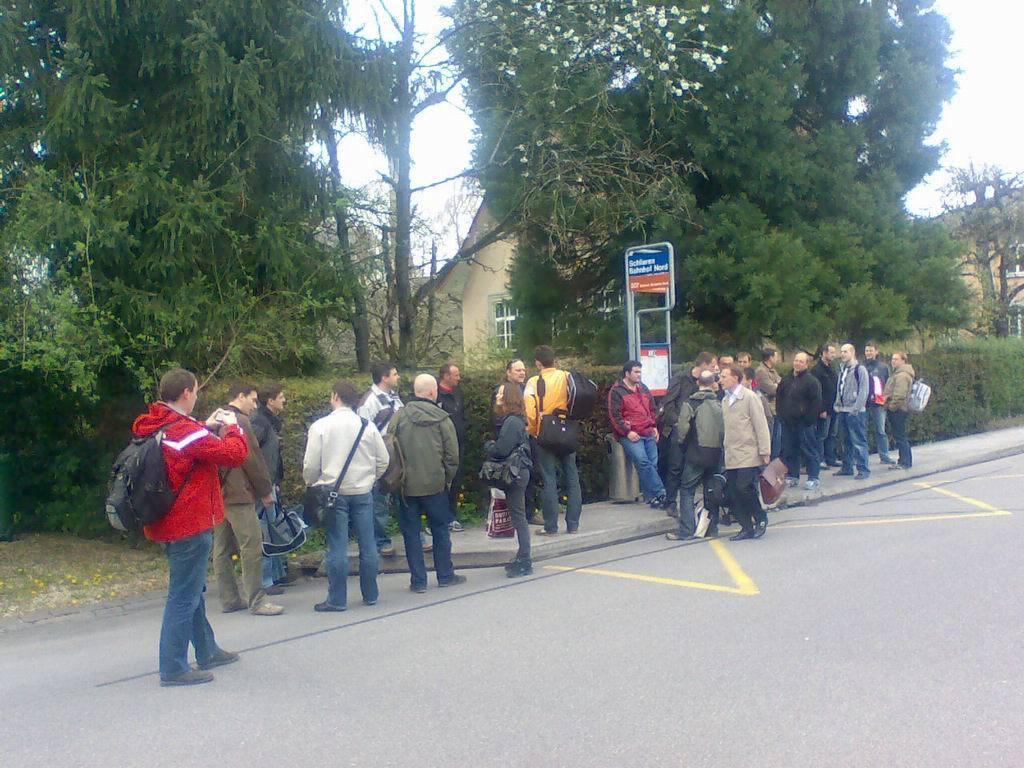Could you give a brief overview of what you see in this image? In the image there are a group of people standing beside the road and behind them there are few trees and plants and behind those trees there are few houses. 